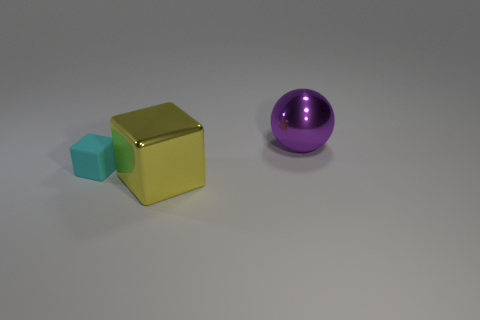What number of other objects are the same material as the tiny thing?
Your answer should be very brief. 0. There is a cube in front of the thing that is to the left of the big object that is in front of the purple ball; how big is it?
Your response must be concise. Large. How many metal objects are either big purple objects or large yellow cubes?
Provide a short and direct response. 2. There is a big yellow thing; is its shape the same as the metallic thing to the right of the large yellow thing?
Give a very brief answer. No. Is the number of objects that are to the left of the big purple metal sphere greater than the number of purple balls that are left of the yellow cube?
Make the answer very short. Yes. Are there any other things of the same color as the metal ball?
Keep it short and to the point. No. There is a big yellow shiny block in front of the large metallic object that is behind the big block; is there a large purple sphere that is on the left side of it?
Your answer should be very brief. No. There is a object that is on the left side of the large cube; is its shape the same as the large yellow thing?
Provide a short and direct response. Yes. Is the number of large yellow shiny objects that are right of the metal sphere less than the number of large blocks in front of the big yellow metallic thing?
Provide a succinct answer. No. What material is the cyan object?
Make the answer very short. Rubber. 